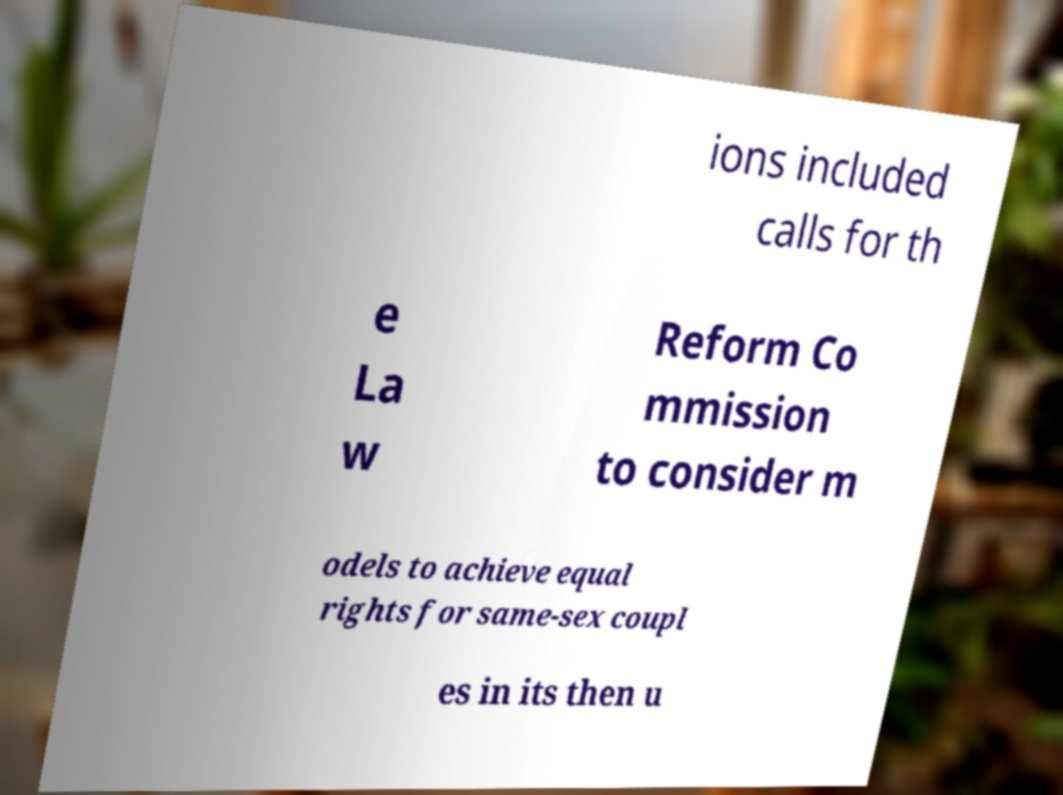Please identify and transcribe the text found in this image. ions included calls for th e La w Reform Co mmission to consider m odels to achieve equal rights for same-sex coupl es in its then u 